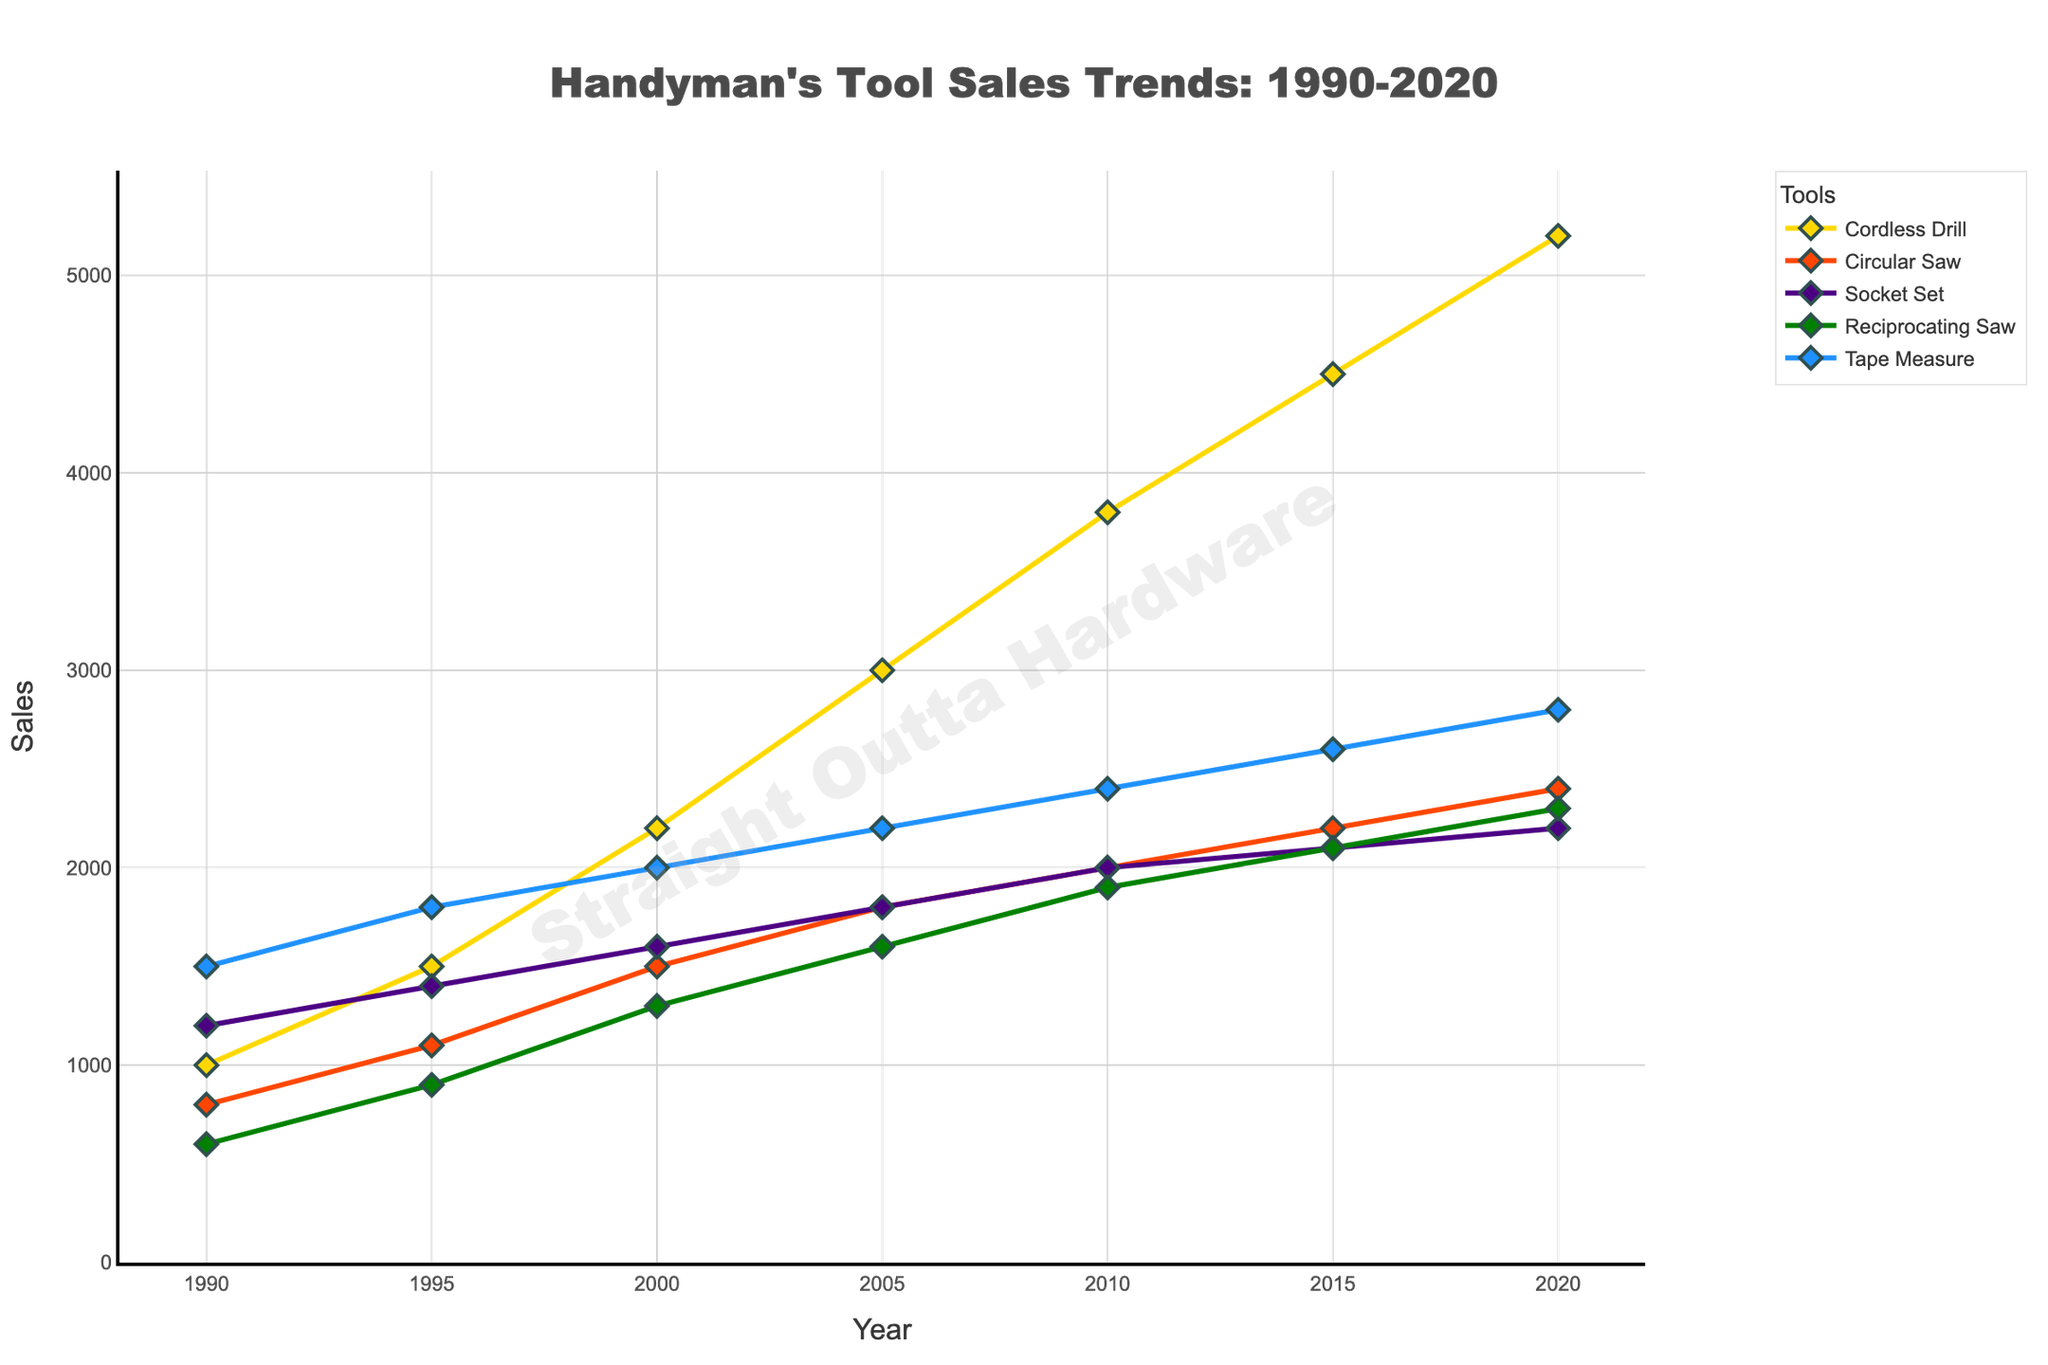Which tool had the highest sales in 2020? The highest sales value in 2020 is 5200, which corresponds to the Cordless Drill
Answer: Cordless Drill What is the average sales of the Circular Saw from 1990 to 2020? Add sales values for Circular Saw for all years: 800 + 1100 + 1500 + 1800 + 2000 + 2200 + 2400 = 11800. Divide the sum by the number of years (7): 11800 / 7 ≈ 1686
Answer: 1686 How does the sales trend of the Socket Set compare to the Reciprocating Saw from 1990 to 2020? From 1990 to 2020, the sales of both tools increased. However, Socket Set sales started higher in 1990 and remained consistently above Reciprocating Saw sales every year.
Answer: Socket Set sales consistently higher What is the total increase in sales for the Tape Measure from 1990 to 2020? Subtract the 1990 sales value from the 2020 sales value: 2800 - 1500 = 1300
Answer: 1300 Between which two consecutive years did the Cordless Drill see the largest sales increase? Calculate the differences between consecutive years: (1500-1000)=500, (2200-1500)=700, (3000-2200)=800, (3800-3000)=800, (4500-3800)=700, (5200-4500)=700. The largest increases are 800 between 2000-2005 and 2005-2010.
Answer: 2000-2005 and 2005-2010 What color represents the Tape Measure trend line? The Tape Measure trend line, as described, is colored blue.
Answer: Blue Which two tools had the same sales value in any year shown, and in which year? In 2015, the sales of Reciprocating Saw and Socket Set both were 2100.
Answer: Reciprocating Saw and Socket Set in 2015 What's the difference in sales between Cordless Drill and Circular Saw in 2010? Subtract the sales of Circular Saw from Cordless Drill in 2010: 3800 - 2000 = 1800
Answer: 1800 Which tool had the smallest growth in sales from 1990 to 2020? The smallest growth is seen in the Circular Saw, with an increase of 2400 - 800 = 1600
Answer: Circular Saw What is the combined total sales of all tools in the year 2000? Add the sales of all tools in the year 2000: 2200 + 1500 + 1600 + 1300 + 2000 = 8600
Answer: 8600 